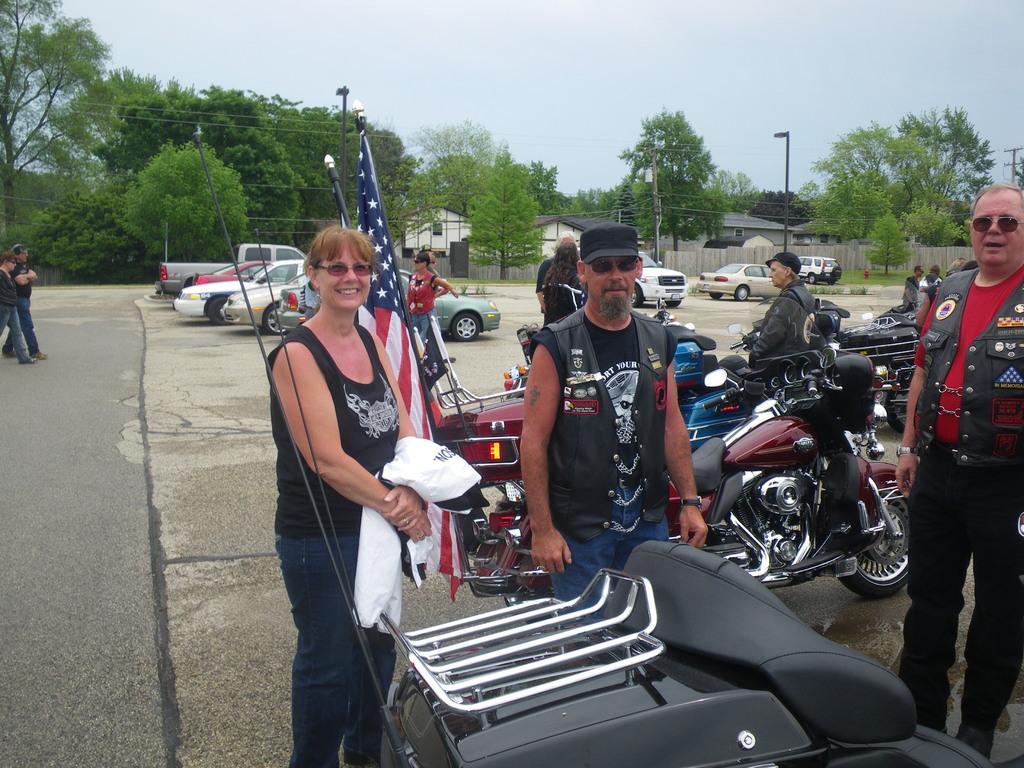In one or two sentences, can you explain what this image depicts? In this picture we can see some vehicles are parked beside the road, few people are standing beside the road and some people are walking on the road, around we can see some houses and trees. 